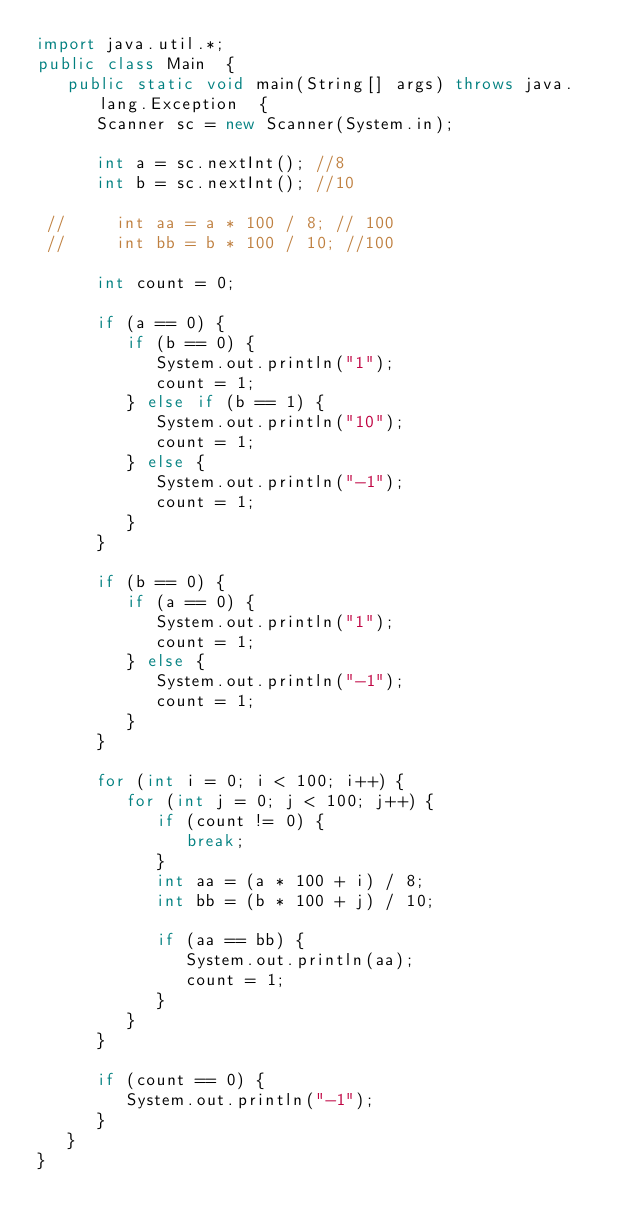<code> <loc_0><loc_0><loc_500><loc_500><_Java_>import java.util.*;
public class Main  {
   public static void main(String[] args) throws java.lang.Exception  {
      Scanner sc = new Scanner(System.in);
               
      int a = sc.nextInt(); //8
      int b = sc.nextInt(); //10
      
 //     int aa = a * 100 / 8; // 100
 //     int bb = b * 100 / 10; //100
      
      int count = 0;
      
      if (a == 0) {
         if (b == 0) {
            System.out.println("1");
            count = 1;
         } else if (b == 1) {
            System.out.println("10");
            count = 1;
         } else {
            System.out.println("-1");
            count = 1;
         }
      }
      
      if (b == 0) {
         if (a == 0) {
            System.out.println("1");
            count = 1;
         } else {
            System.out.println("-1");
            count = 1;
         }
      }
      
      for (int i = 0; i < 100; i++) {
         for (int j = 0; j < 100; j++) {
            if (count != 0) {
               break;
            }
            int aa = (a * 100 + i) / 8;
            int bb = (b * 100 + j) / 10;
               
            if (aa == bb) {
               System.out.println(aa);
               count = 1;
            }
         }   
      }
      
      if (count == 0) {
         System.out.println("-1");
      }
   }        
}</code> 